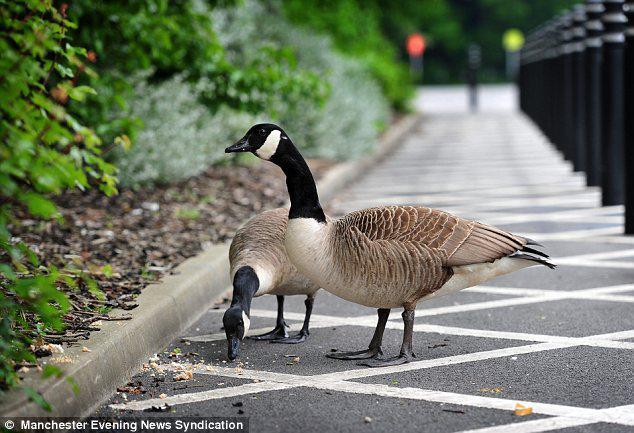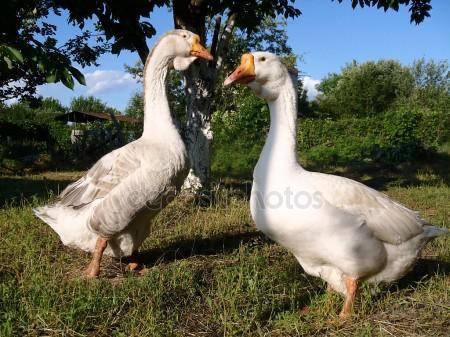The first image is the image on the left, the second image is the image on the right. For the images shown, is this caption "At least one image includes two birds standing face to face on dry land in the foreground." true? Answer yes or no. Yes. The first image is the image on the left, the second image is the image on the right. Analyze the images presented: Is the assertion "The birds in the image on the right are near a body of water." valid? Answer yes or no. No. 